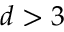Convert formula to latex. <formula><loc_0><loc_0><loc_500><loc_500>d > 3</formula> 